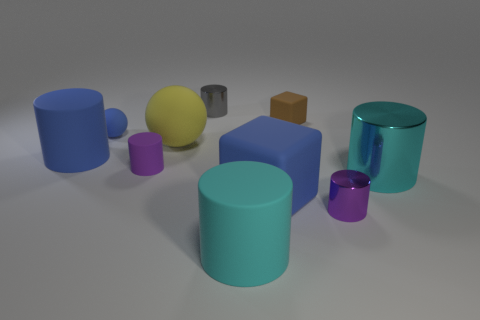What number of other things are there of the same material as the small blue ball
Ensure brevity in your answer.  6. Do the block in front of the big ball and the large matte cylinder that is on the right side of the blue cylinder have the same color?
Your answer should be very brief. No. What is the shape of the big rubber thing in front of the small shiny thing that is in front of the gray cylinder?
Offer a very short reply. Cylinder. What number of other objects are the same color as the small rubber cylinder?
Offer a terse response. 1. Do the tiny cylinder that is in front of the tiny matte cylinder and the big blue object to the left of the tiny gray object have the same material?
Your response must be concise. No. What size is the ball that is behind the large matte sphere?
Your answer should be compact. Small. There is a tiny object that is the same shape as the large yellow thing; what is it made of?
Your response must be concise. Rubber. Are there any other things that are the same size as the yellow thing?
Give a very brief answer. Yes. The blue rubber object in front of the big blue matte cylinder has what shape?
Your answer should be compact. Cube. What number of cyan metal objects are the same shape as the gray metallic thing?
Provide a short and direct response. 1. 